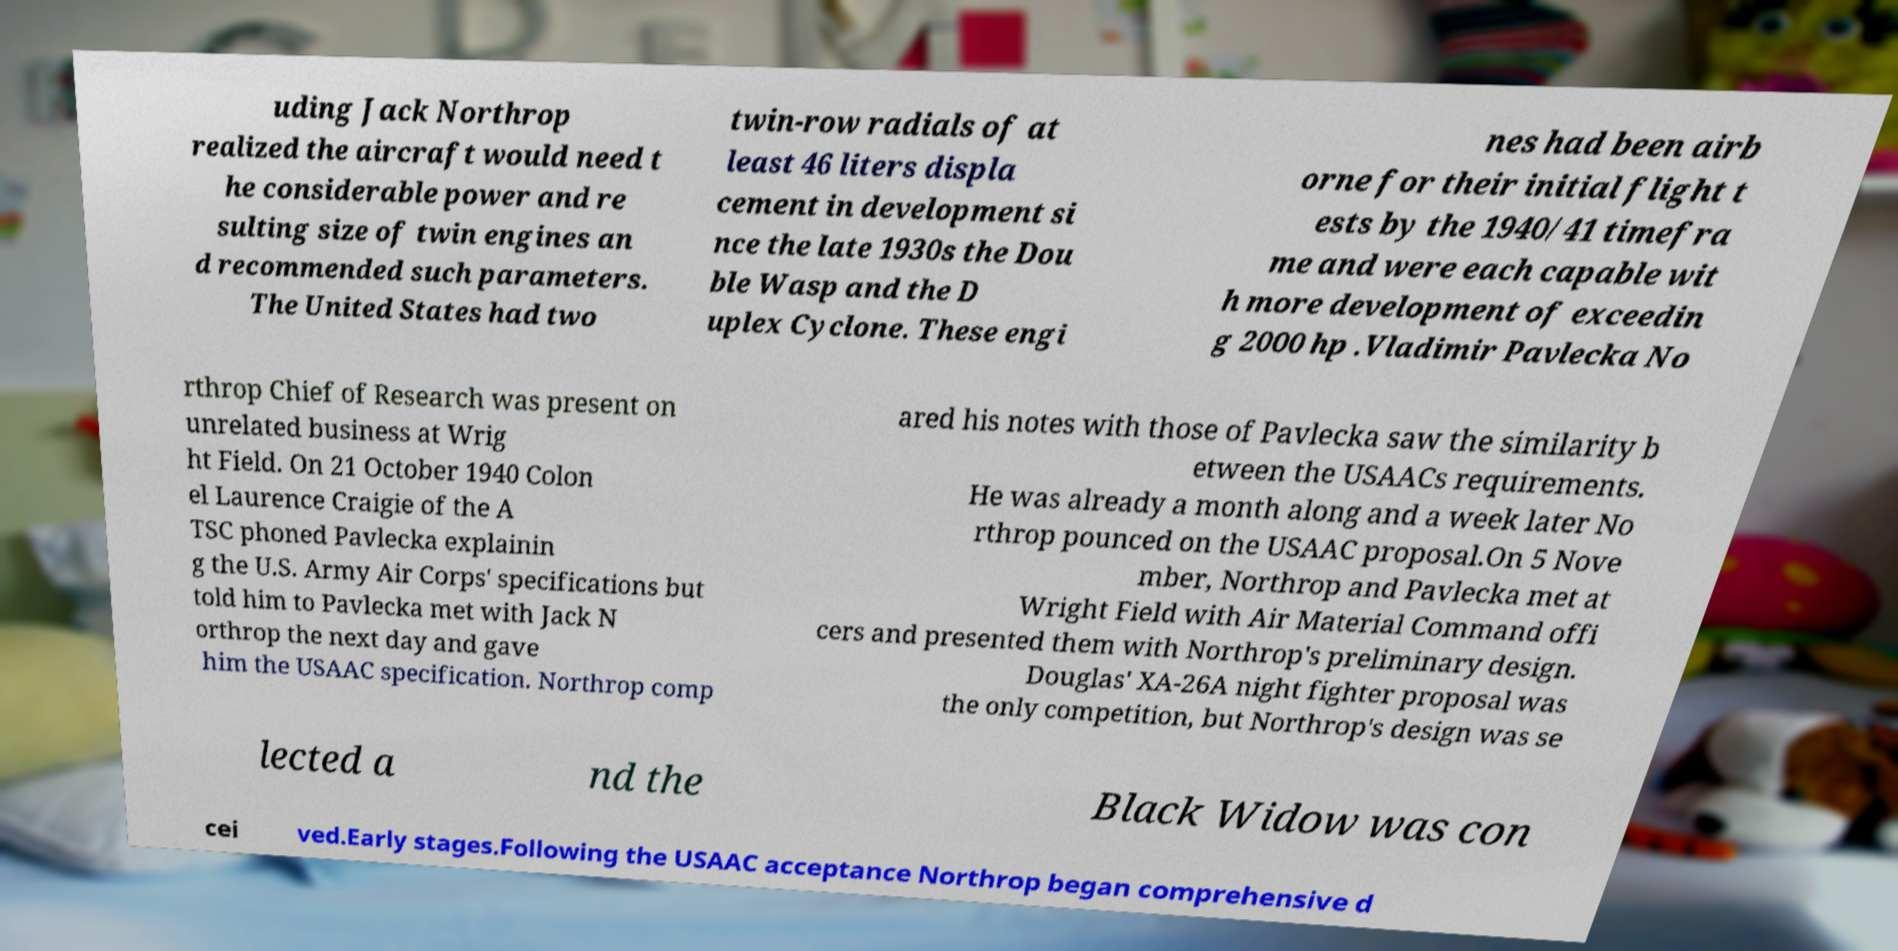Please identify and transcribe the text found in this image. uding Jack Northrop realized the aircraft would need t he considerable power and re sulting size of twin engines an d recommended such parameters. The United States had two twin-row radials of at least 46 liters displa cement in development si nce the late 1930s the Dou ble Wasp and the D uplex Cyclone. These engi nes had been airb orne for their initial flight t ests by the 1940/41 timefra me and were each capable wit h more development of exceedin g 2000 hp .Vladimir Pavlecka No rthrop Chief of Research was present on unrelated business at Wrig ht Field. On 21 October 1940 Colon el Laurence Craigie of the A TSC phoned Pavlecka explainin g the U.S. Army Air Corps' specifications but told him to Pavlecka met with Jack N orthrop the next day and gave him the USAAC specification. Northrop comp ared his notes with those of Pavlecka saw the similarity b etween the USAACs requirements. He was already a month along and a week later No rthrop pounced on the USAAC proposal.On 5 Nove mber, Northrop and Pavlecka met at Wright Field with Air Material Command offi cers and presented them with Northrop's preliminary design. Douglas' XA-26A night fighter proposal was the only competition, but Northrop's design was se lected a nd the Black Widow was con cei ved.Early stages.Following the USAAC acceptance Northrop began comprehensive d 